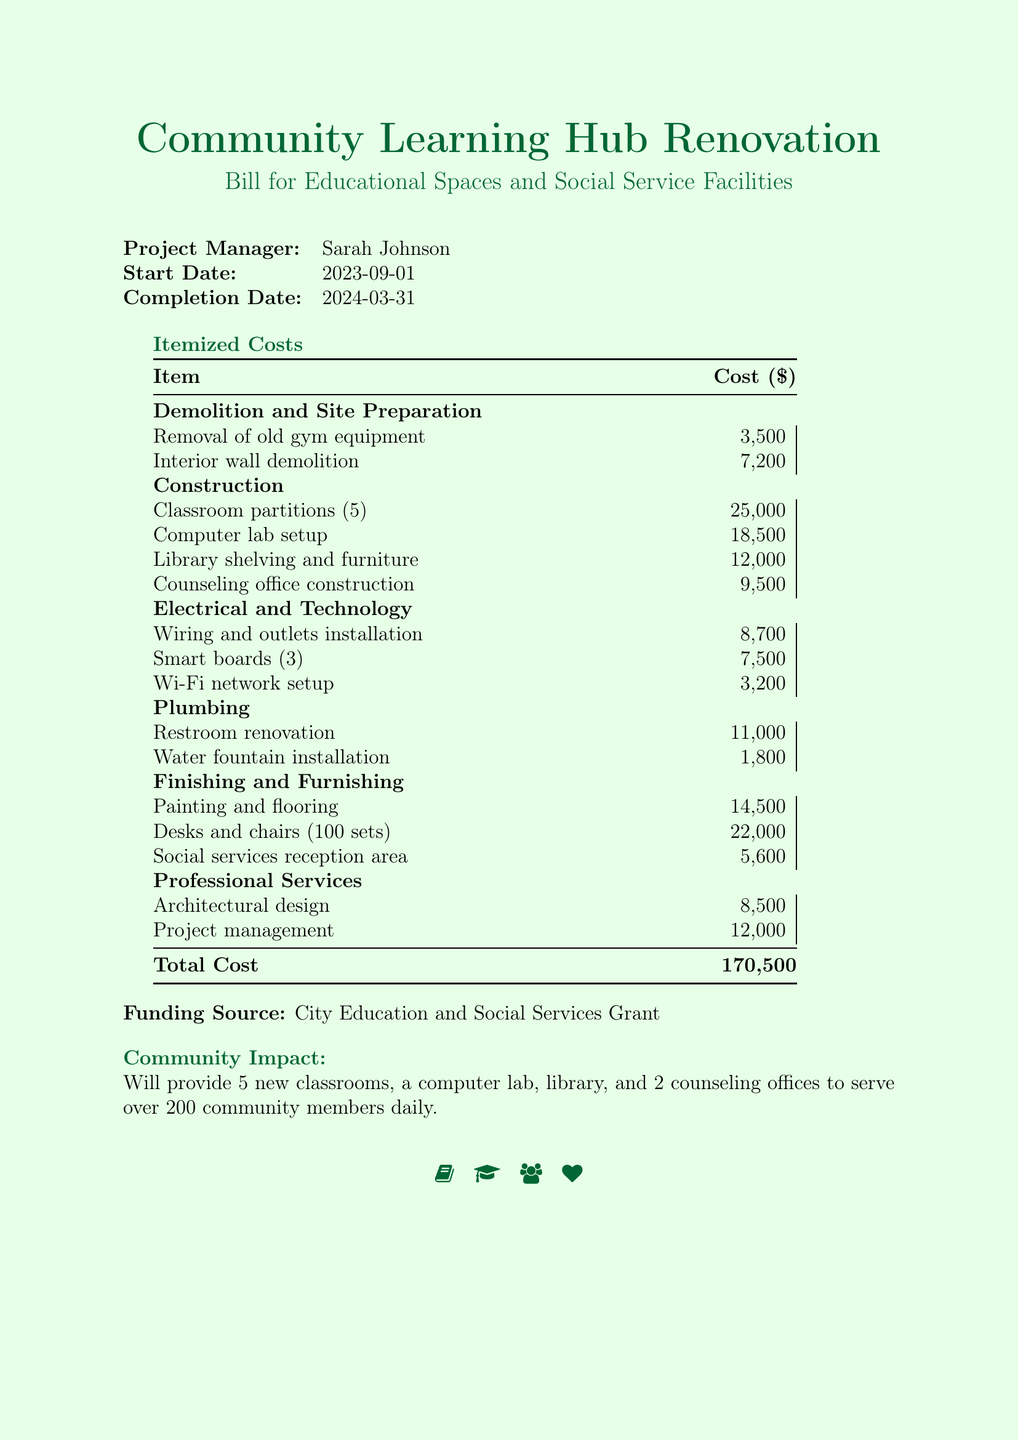What is the project manager's name? The project manager's name is mentioned in the document.
Answer: Sarah Johnson What is the total cost of the renovation? The total cost is given at the bottom of the itemized costs table.
Answer: 170,500 How many classrooms will be provided? The community impact section states the number of new classrooms being provided.
Answer: 5 What is the cost for the computer lab setup? The itemized costs list includes the specific cost for the computer lab setup.
Answer: 18,500 What is the funding source for this project? The document mentions the source of funding in a dedicated section.
Answer: City Education and Social Services Grant What is the completion date of the project? The completion date is listed in a tabular format along with the start date.
Answer: 2024-03-31 How many counseling offices will be constructed? The document explicitly states the number of counseling offices in the community impact section.
Answer: 2 What is the cost for the architectural design? The itemized costs list specifies the cost associated with architectural design.
Answer: 8,500 What kind of facilities will be included in this renovation? The document outlines the types of educational spaces and social service facilities being created.
Answer: Classrooms, computer lab, library, counseling offices 